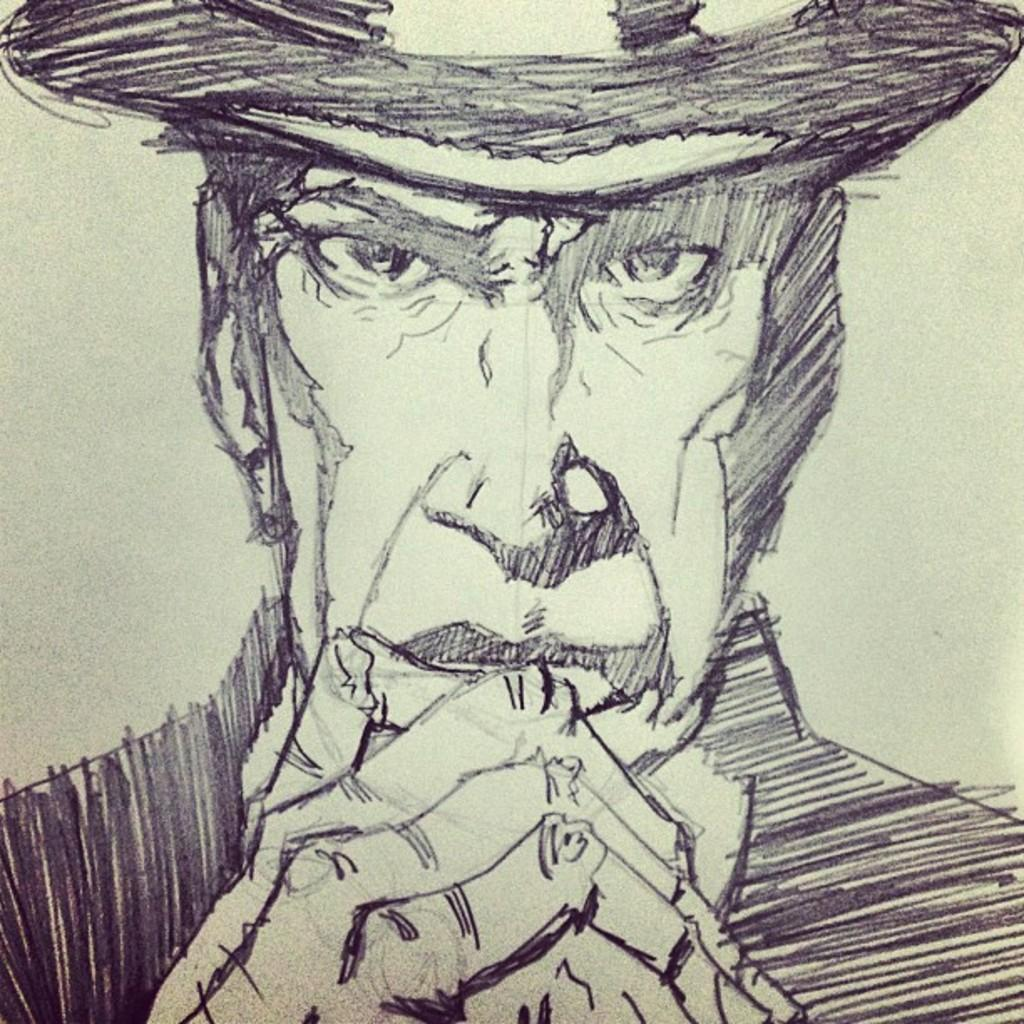What is depicted in the image? There is a drawing of a man in the image. What is the man wearing on his head? The man is wearing something on his head. How many islands can be seen in the drawing of the man? There are no islands depicted in the drawing of the man; it is a drawing of a man wearing something on his head. What type of peace symbol is present in the drawing of the man? There is no peace symbol present in the drawing of the man; it is a drawing of a man wearing something on his head. 